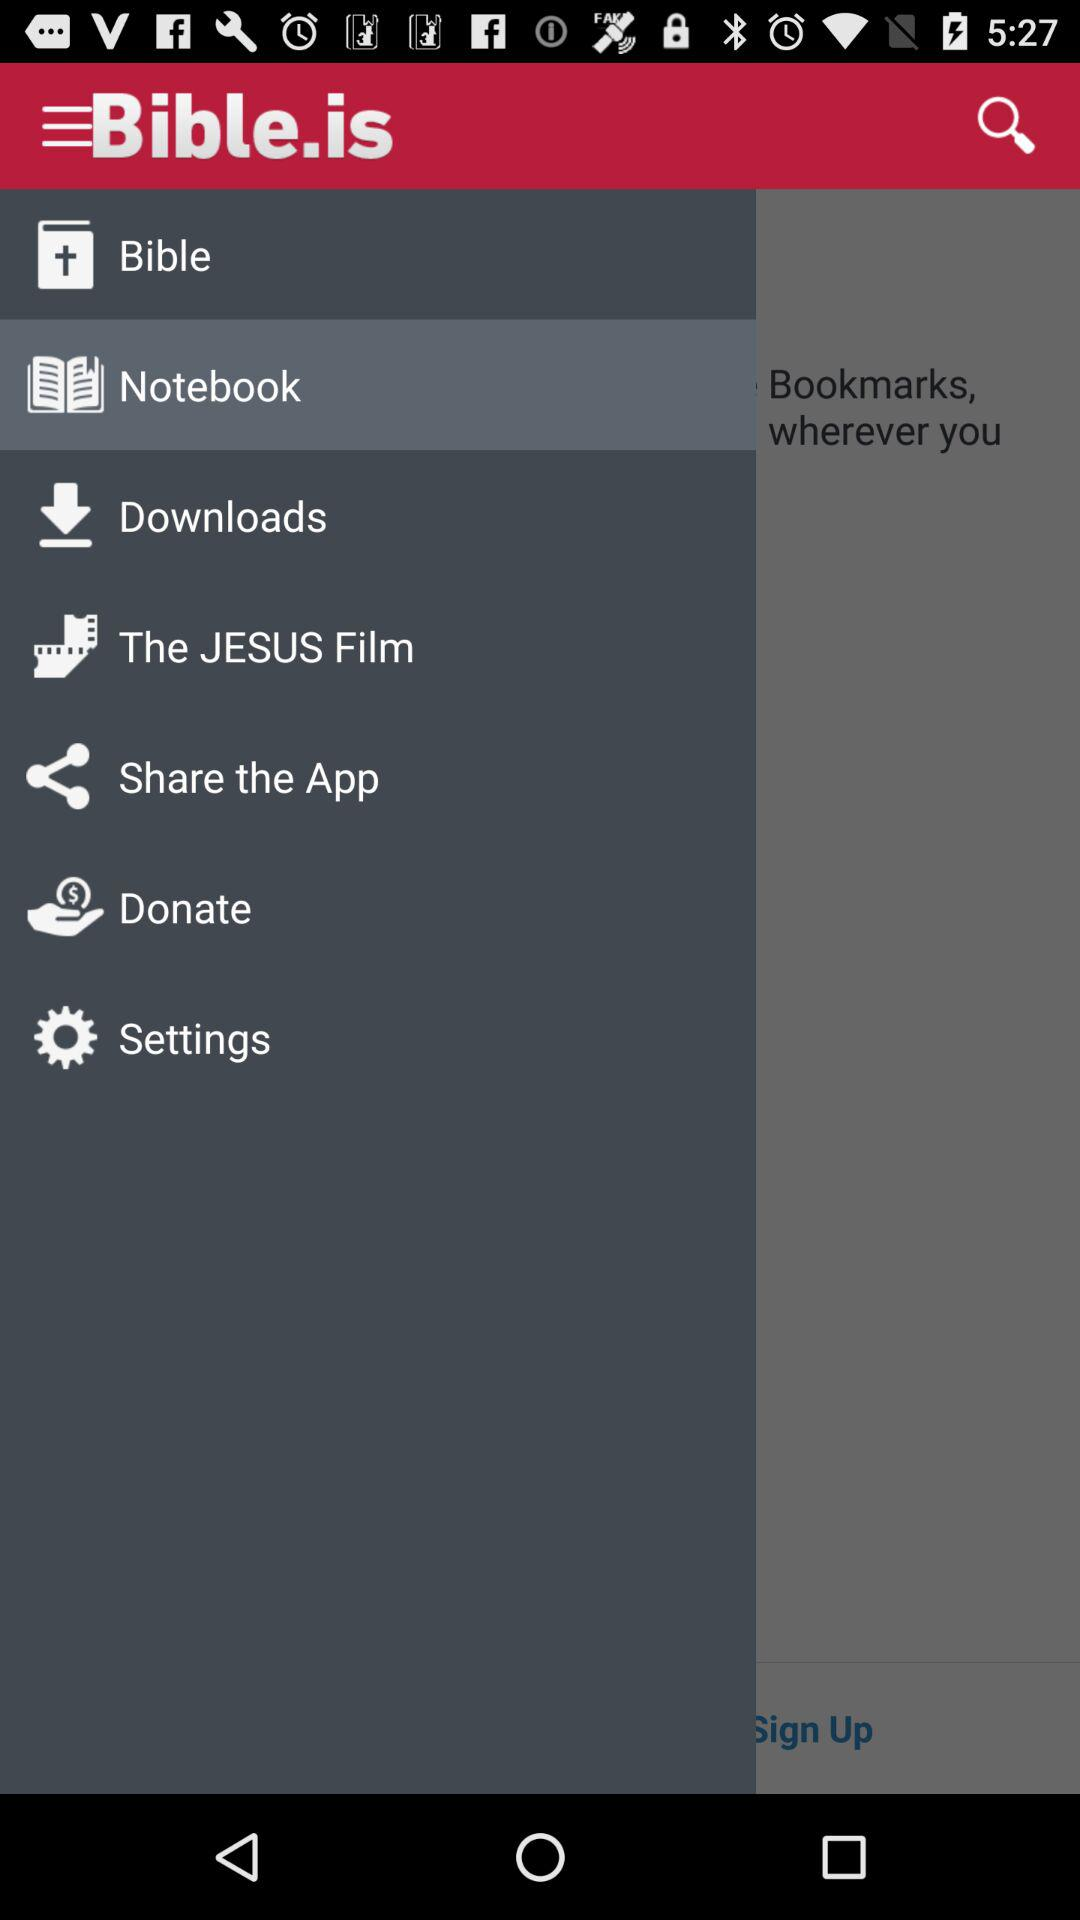What is the application name? The application name is "Bible.is". 